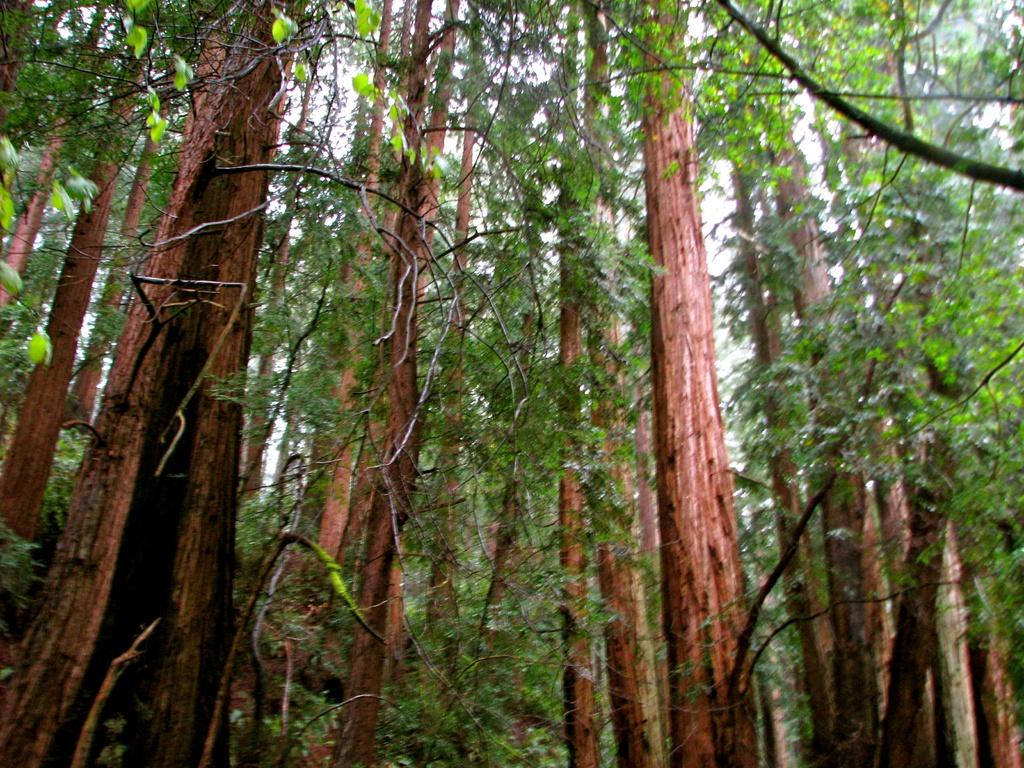What type of vegetation can be seen in the image? There are trees in the image. What is visible at the top of the image? The sky is visible at the top of the image. Where is the advertisement for the sponge route located in the image? There is no advertisement or sponge route present in the image. What type of sponge can be seen in the image? There are no sponges present in the image. 